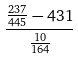<formula> <loc_0><loc_0><loc_500><loc_500>\frac { \frac { 2 3 7 } { 4 4 5 } - 4 3 1 } { \frac { 1 0 } { 1 6 4 } }</formula> 